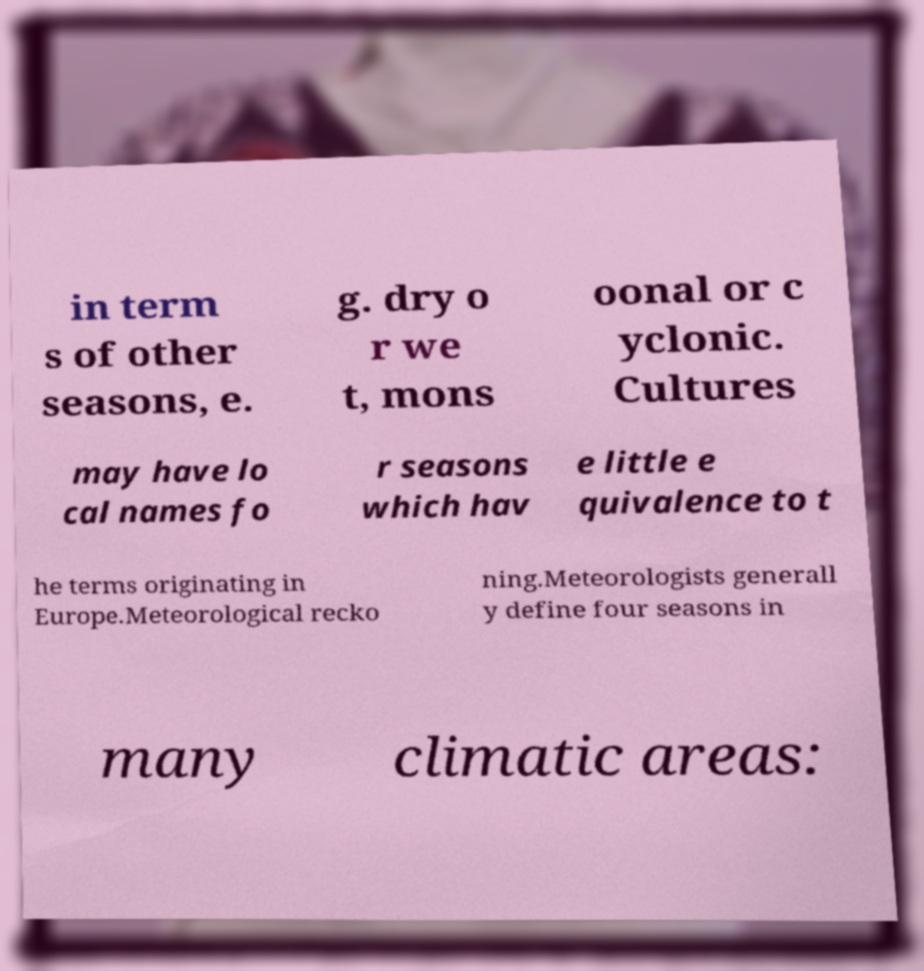Please identify and transcribe the text found in this image. in term s of other seasons, e. g. dry o r we t, mons oonal or c yclonic. Cultures may have lo cal names fo r seasons which hav e little e quivalence to t he terms originating in Europe.Meteorological recko ning.Meteorologists generall y define four seasons in many climatic areas: 